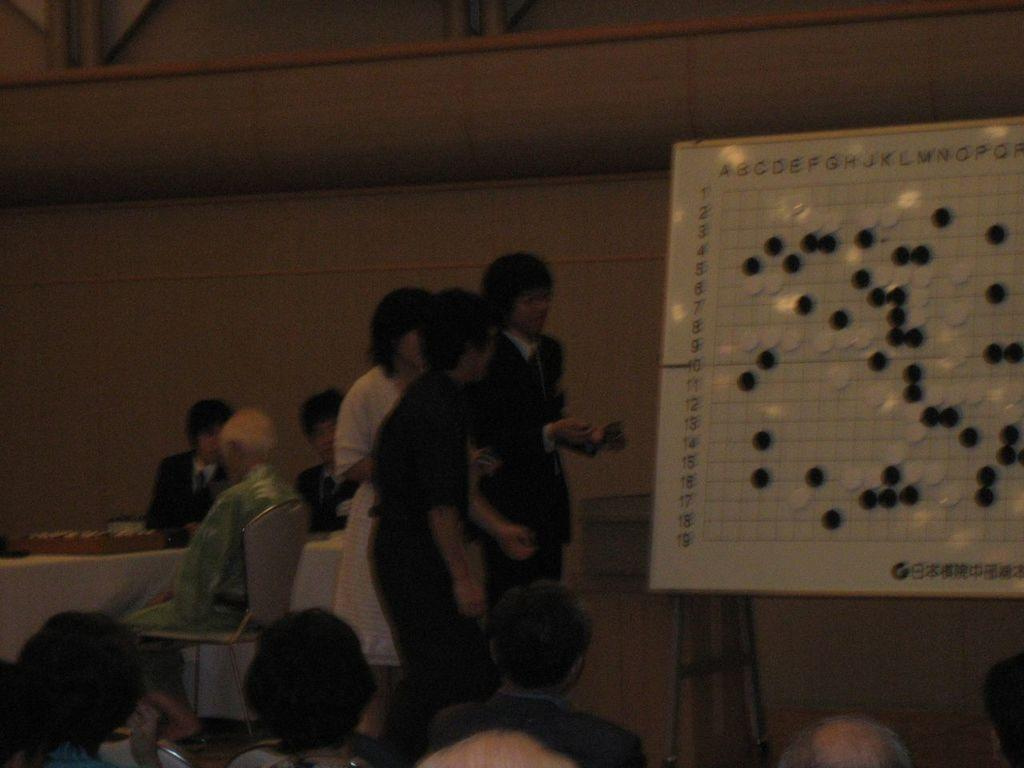Who or what is present in the image? There are people in the image. What are the people sitting on in the image? There are chairs in the image. What is the board used for in the image? There is a board in the image, and it has objects on it. How many ideas can be seen on the board in the image? There is no mention of ideas in the image; the board has objects on it. 